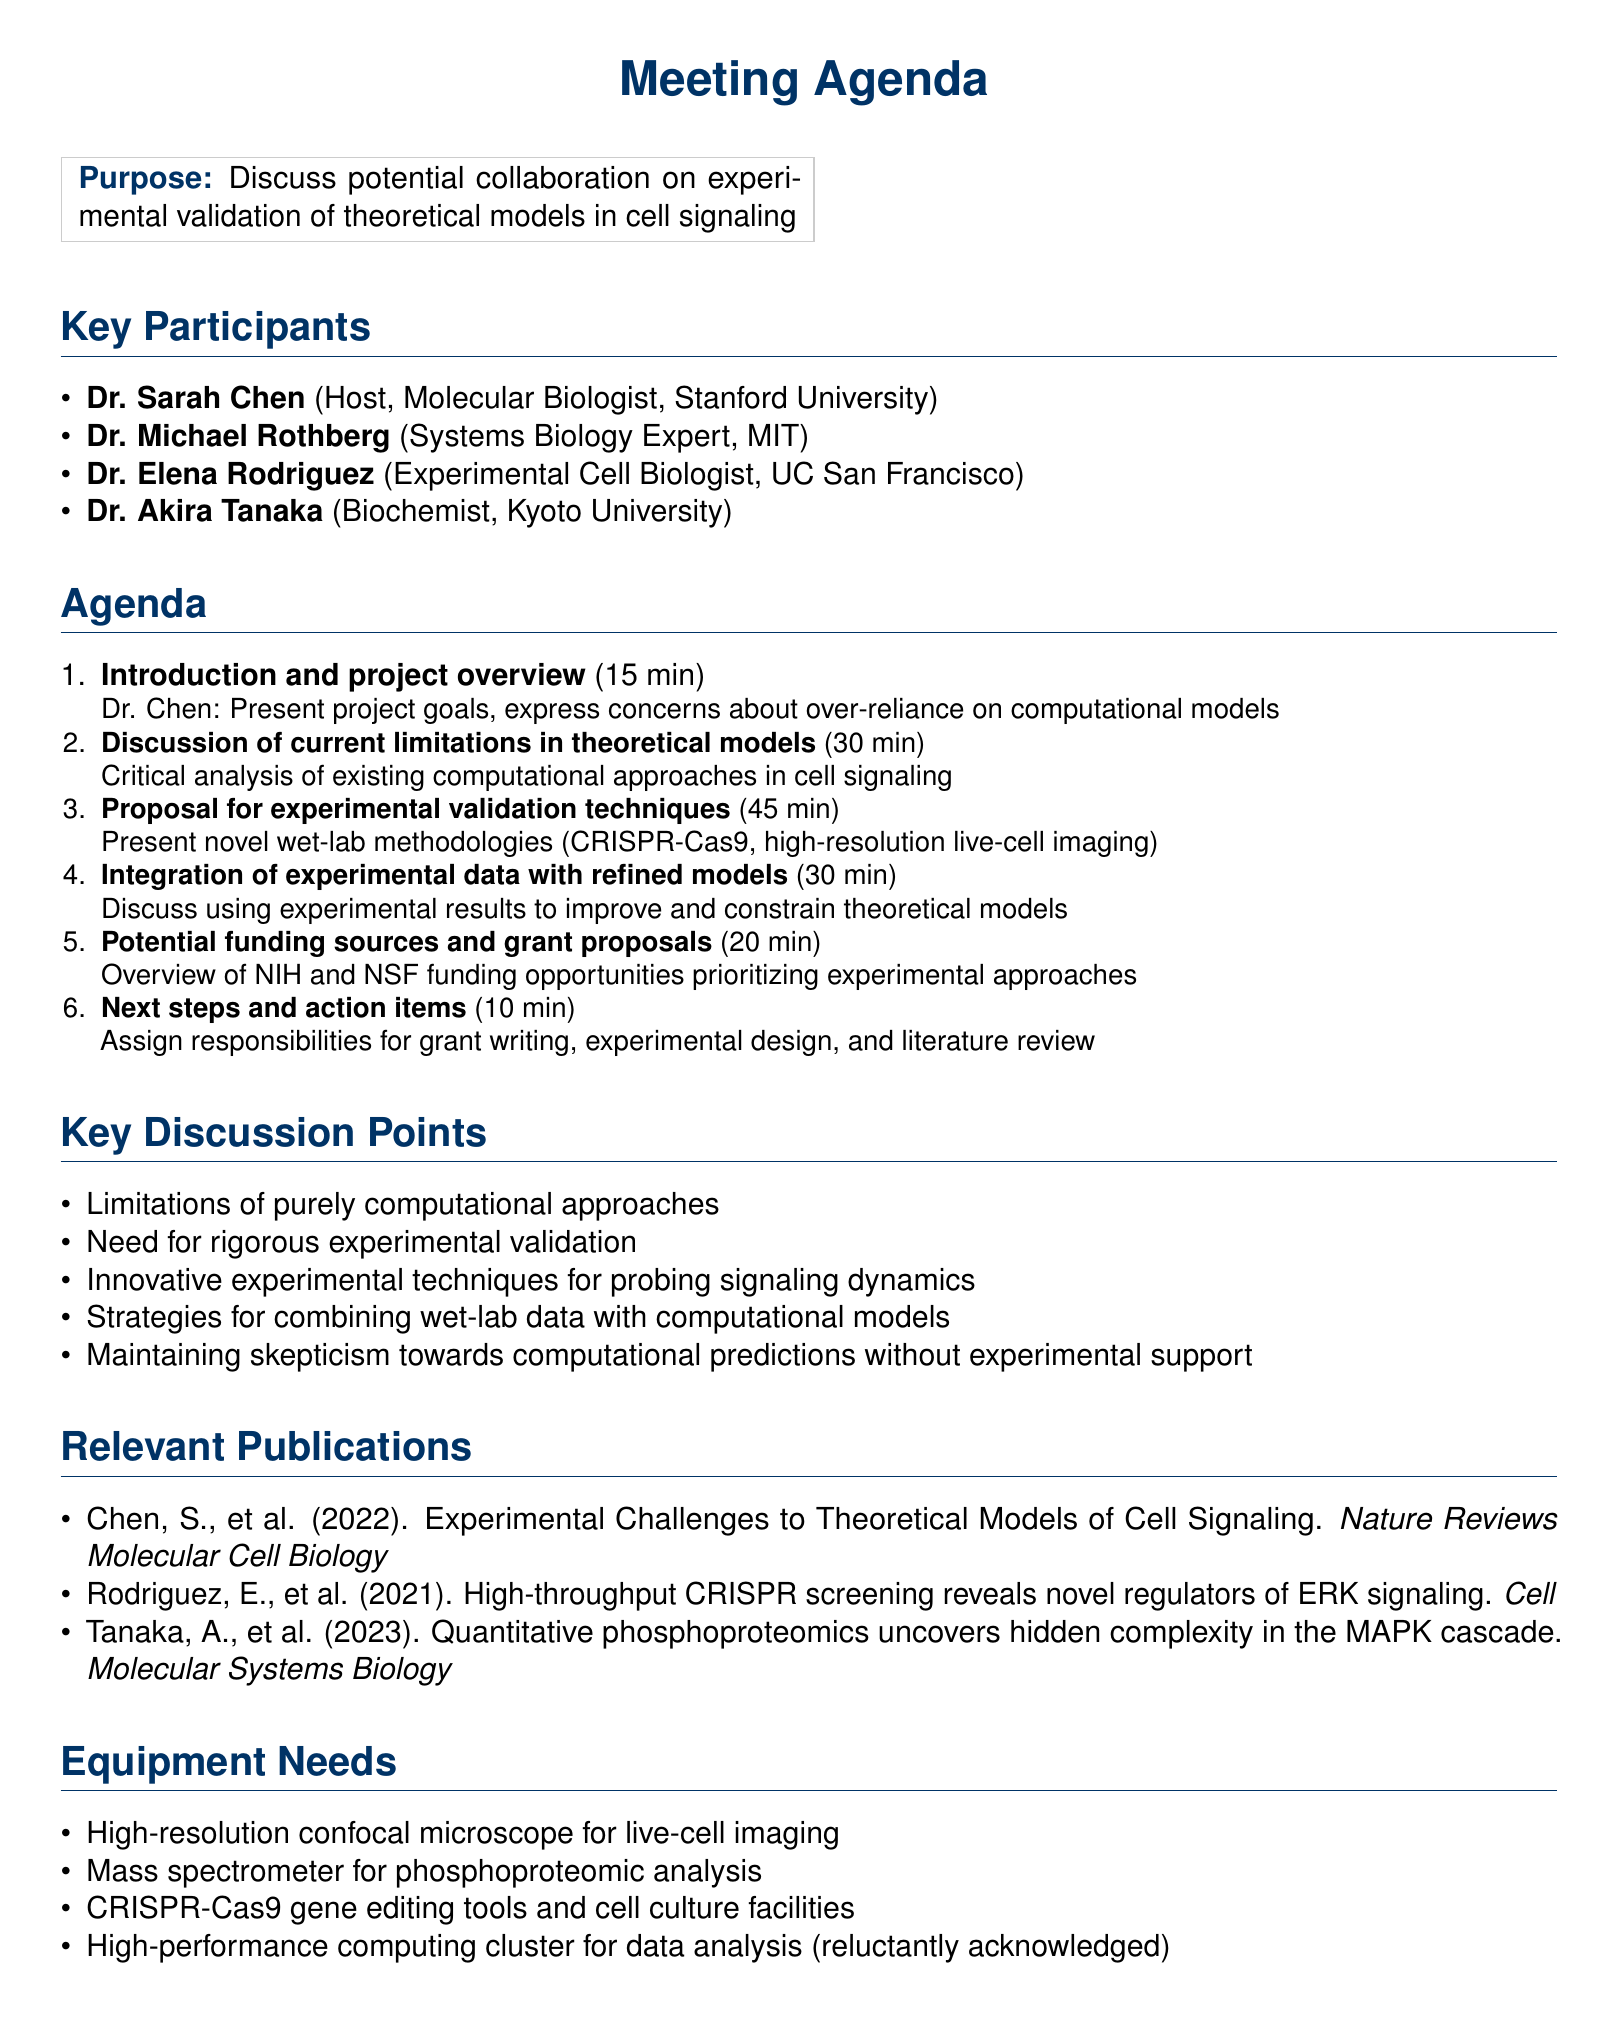what is the main purpose of the meeting? The purpose of the meeting is to discuss potential collaboration on experimental validation of theoretical models in cell signaling.
Answer: discuss potential collaboration on experimental validation of theoretical models in cell signaling who is the host of the meeting? The host of the meeting is Dr. Sarah Chen.
Answer: Dr. Sarah Chen how long is the discussion on current limitations in theoretical models scheduled to last? The discussion of current limitations in theoretical models is scheduled for thirty minutes.
Answer: 30 minutes what novel techniques will be proposed for experimental validation? The proposed techniques include CRISPR-Cas9 gene editing and high-resolution live-cell imaging.
Answer: CRISPR-Cas9 gene editing and high-resolution live-cell imaging which institution is Dr. Elena Rodriguez affiliated with? Dr. Elena Rodriguez is affiliated with UC San Francisco.
Answer: UC San Francisco what is the last agenda item in the meeting? The last agenda item is about next steps and action items.
Answer: next steps and action items what type of funding opportunities will be overviewed in the meeting? The overview will focus on NIH and NSF funding opportunities.
Answer: NIH and NSF funding opportunities what is one of the key discussion points mentioned in the agenda? One of the key discussion points is the limitations of purely computational approaches in understanding complex biological systems.
Answer: limitations of purely computational approaches in understanding complex biological systems what is the duration for the integration of experimental data with refined models? The integration of experimental data with refined models will last thirty minutes.
Answer: 30 minutes 